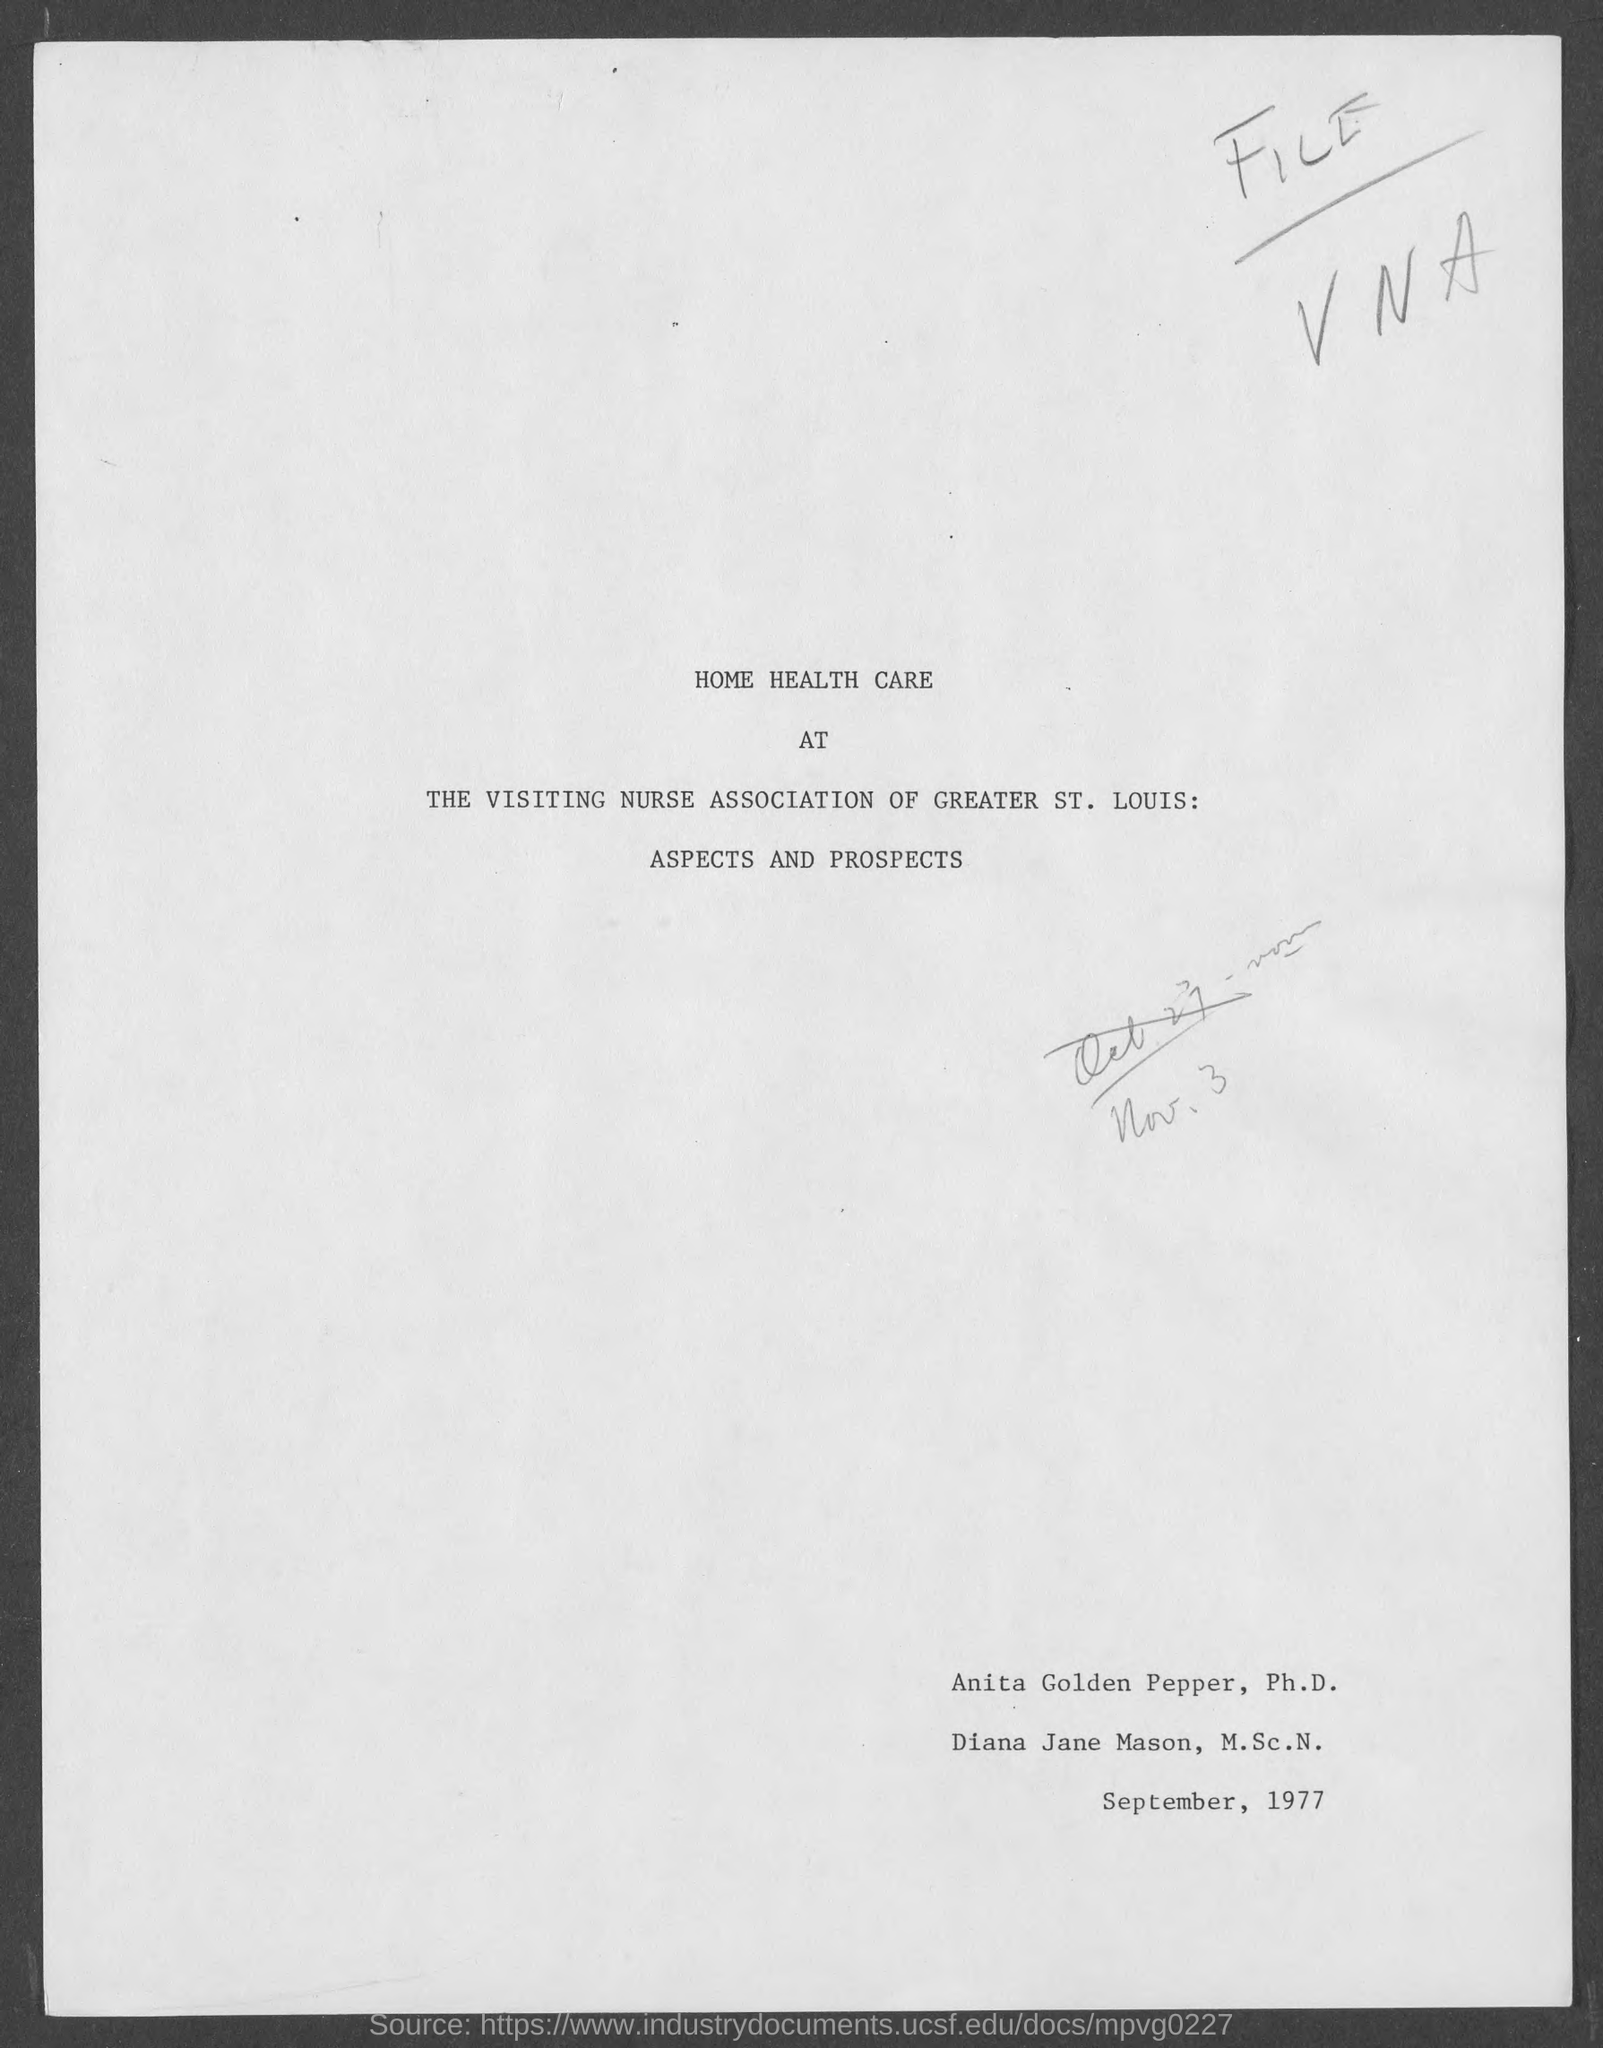What is the name of the first person in the document?
Keep it short and to the point. Anita Golden Pepper. What is the name of the second person in the document?
Provide a succinct answer. Diana Jane Mason. 